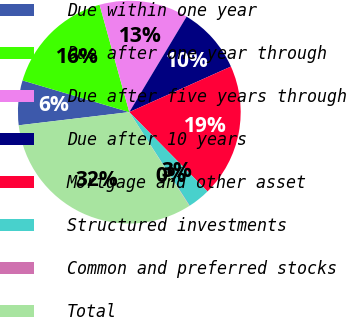Convert chart to OTSL. <chart><loc_0><loc_0><loc_500><loc_500><pie_chart><fcel>Due within one year<fcel>Due after one year through<fcel>Due after five years through<fcel>Due after 10 years<fcel>Mortgage and other asset<fcel>Structured investments<fcel>Common and preferred stocks<fcel>Total<nl><fcel>6.48%<fcel>16.11%<fcel>12.9%<fcel>9.69%<fcel>19.33%<fcel>3.26%<fcel>0.05%<fcel>32.18%<nl></chart> 